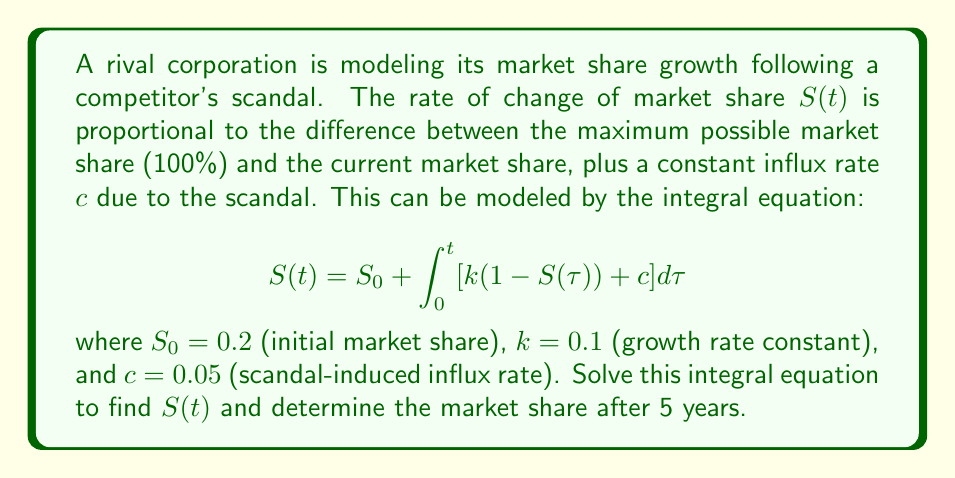Could you help me with this problem? To solve this integral equation, we'll follow these steps:

1) First, differentiate both sides with respect to $t$:
   $$\frac{dS}{dt} = k(1-S(t)) + c$$

2) This is a first-order linear differential equation. Rearrange it:
   $$\frac{dS}{dt} + kS = k + c$$

3) The integrating factor is $e^{kt}$. Multiply both sides by this:
   $$e^{kt}\frac{dS}{dt} + ke^{kt}S = (k+c)e^{kt}$$

4) The left side is now the derivative of $e^{kt}S$. Integrate both sides:
   $$e^{kt}S = \frac{k+c}{k}e^{kt} + C$$

5) Solve for $S(t)$:
   $$S(t) = \frac{k+c}{k} + Ce^{-kt}$$

6) Use the initial condition $S(0) = S_0 = 0.2$ to find $C$:
   $$0.2 = \frac{0.1+0.05}{0.1} + C$$
   $$C = 0.2 - 1.5 = -1.3$$

7) Therefore, the solution is:
   $$S(t) = 1.5 - 1.3e^{-0.1t}$$

8) To find the market share after 5 years, calculate $S(5)$:
   $$S(5) = 1.5 - 1.3e^{-0.5} \approx 0.7101$$

Thus, after 5 years, the market share will be approximately 71.01%.
Answer: $S(t) = 1.5 - 1.3e^{-0.1t}$; Market share after 5 years: 71.01% 